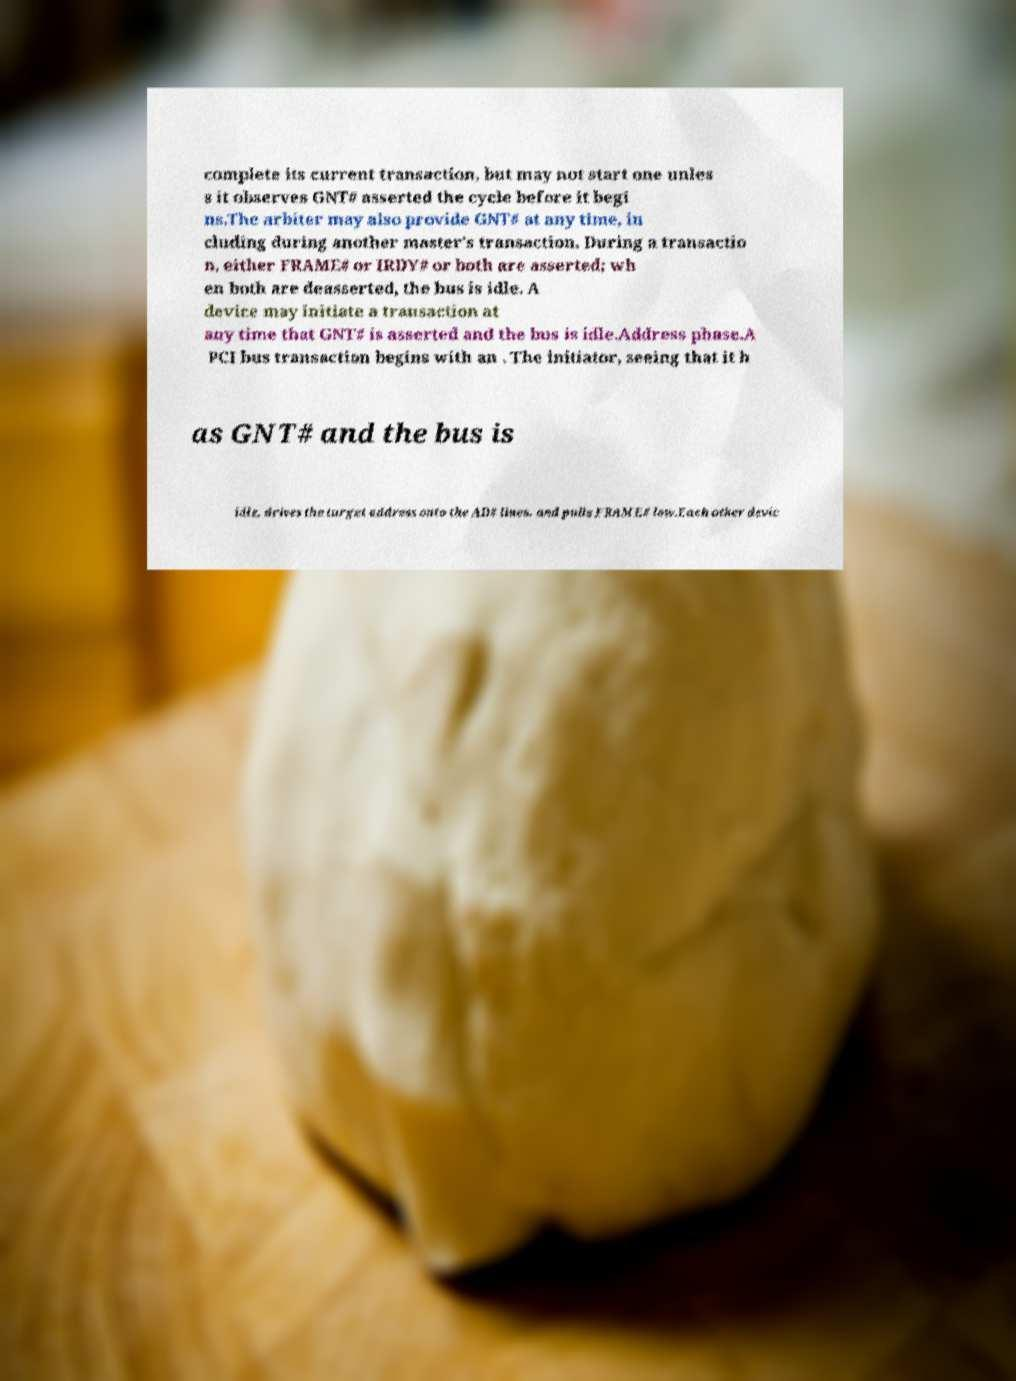For documentation purposes, I need the text within this image transcribed. Could you provide that? complete its current transaction, but may not start one unles s it observes GNT# asserted the cycle before it begi ns.The arbiter may also provide GNT# at any time, in cluding during another master's transaction. During a transactio n, either FRAME# or IRDY# or both are asserted; wh en both are deasserted, the bus is idle. A device may initiate a transaction at any time that GNT# is asserted and the bus is idle.Address phase.A PCI bus transaction begins with an . The initiator, seeing that it h as GNT# and the bus is idle, drives the target address onto the AD# lines, and pulls FRAME# low.Each other devic 